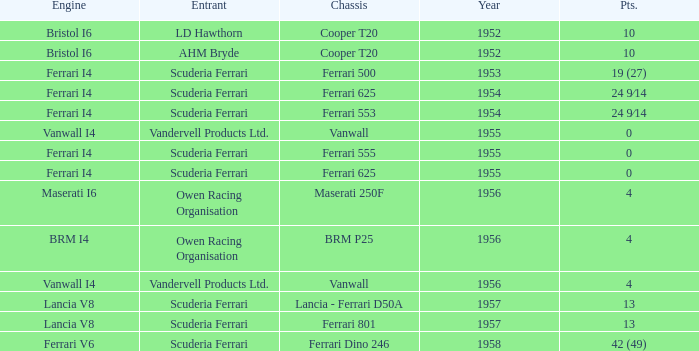How many points were scored when the Chassis is BRM p25? 4.0. 